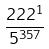Convert formula to latex. <formula><loc_0><loc_0><loc_500><loc_500>\frac { 2 2 2 ^ { 1 } } { 5 ^ { 3 5 7 } }</formula> 